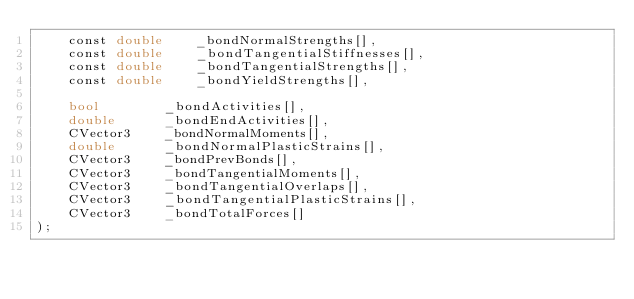Convert code to text. <code><loc_0><loc_0><loc_500><loc_500><_Cuda_>	const double	_bondNormalStrengths[],
	const double	_bondTangentialStiffnesses[],
	const double	_bondTangentialStrengths[],
	const double	_bondYieldStrengths[],

	bool		_bondActivities[],
	double		_bondEndActivities[],
	CVector3	_bondNormalMoments[],
	double		_bondNormalPlasticStrains[],
	CVector3	_bondPrevBonds[],
	CVector3	_bondTangentialMoments[],
	CVector3	_bondTangentialOverlaps[],
	CVector3	_bondTangentialPlasticStrains[],
	CVector3	_bondTotalForces[]
);


 </code> 